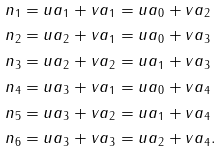Convert formula to latex. <formula><loc_0><loc_0><loc_500><loc_500>n _ { 1 } & = u a _ { 1 } + v a _ { 1 } = u a _ { 0 } + v a _ { 2 } \\ n _ { 2 } & = u a _ { 2 } + v a _ { 1 } = u a _ { 0 } + v a _ { 3 } \\ n _ { 3 } & = u a _ { 2 } + v a _ { 2 } = u a _ { 1 } + v a _ { 3 } \\ n _ { 4 } & = u a _ { 3 } + v a _ { 1 } = u a _ { 0 } + v a _ { 4 } \\ n _ { 5 } & = u a _ { 3 } + v a _ { 2 } = u a _ { 1 } + v a _ { 4 } \\ n _ { 6 } & = u a _ { 3 } + v a _ { 3 } = u a _ { 2 } + v a _ { 4 } .</formula> 